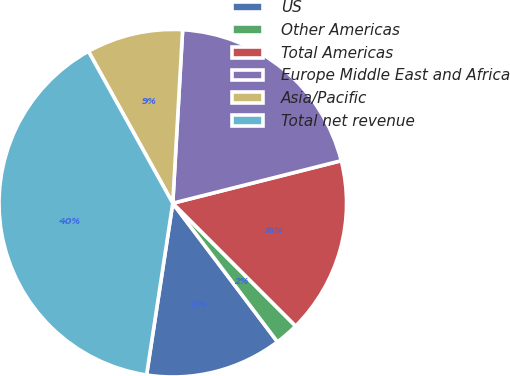Convert chart to OTSL. <chart><loc_0><loc_0><loc_500><loc_500><pie_chart><fcel>US<fcel>Other Americas<fcel>Total Americas<fcel>Europe Middle East and Africa<fcel>Asia/Pacific<fcel>Total net revenue<nl><fcel>12.7%<fcel>2.21%<fcel>16.43%<fcel>20.16%<fcel>8.97%<fcel>39.52%<nl></chart> 